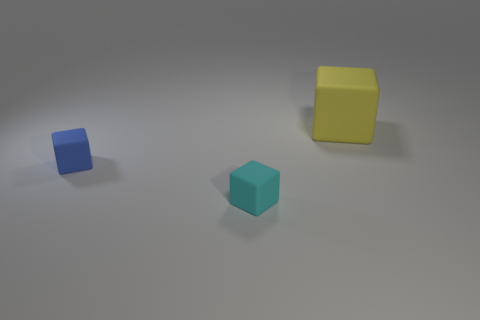There is a big yellow rubber object; is it the same shape as the matte object that is in front of the tiny blue rubber cube?
Provide a short and direct response. Yes. What number of big objects are either blue metallic blocks or matte blocks?
Ensure brevity in your answer.  1. The matte object on the left side of the cube in front of the blue matte cube is what color?
Ensure brevity in your answer.  Blue. Do the large object and the tiny cube that is on the left side of the tiny cyan matte cube have the same material?
Ensure brevity in your answer.  Yes. There is a cube in front of the tiny blue rubber thing; what is it made of?
Offer a very short reply. Rubber. Is the number of small matte things that are in front of the yellow cube the same as the number of large rubber objects?
Make the answer very short. No. Is there any other thing that is the same size as the cyan rubber object?
Your answer should be very brief. Yes. There is a large yellow object that is behind the small block that is in front of the blue object; what is it made of?
Ensure brevity in your answer.  Rubber. There is a matte thing that is on the right side of the small blue rubber thing and left of the yellow rubber block; what shape is it?
Give a very brief answer. Cube. What is the size of the cyan thing that is the same shape as the tiny blue thing?
Keep it short and to the point. Small. 